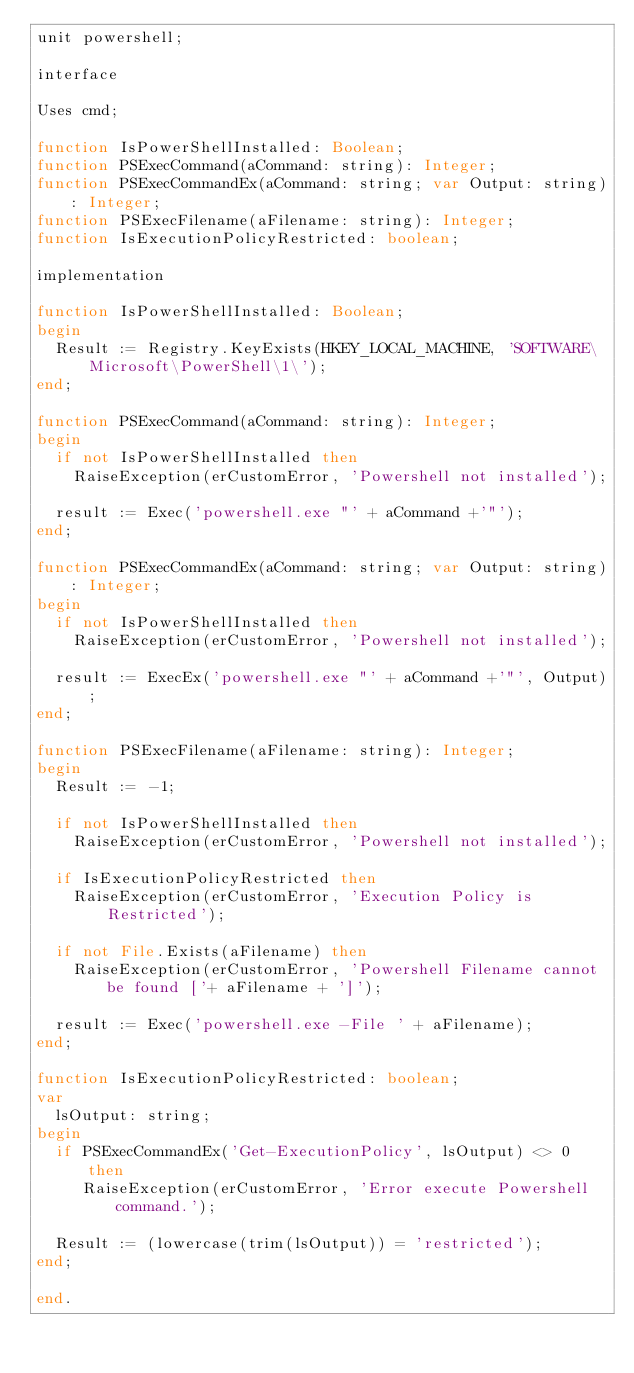Convert code to text. <code><loc_0><loc_0><loc_500><loc_500><_Pascal_>unit powershell;

interface

Uses cmd;

function IsPowerShellInstalled: Boolean;
function PSExecCommand(aCommand: string): Integer;
function PSExecCommandEx(aCommand: string; var Output: string): Integer;
function PSExecFilename(aFilename: string): Integer;
function IsExecutionPolicyRestricted: boolean;

implementation

function IsPowerShellInstalled: Boolean;
begin
  Result := Registry.KeyExists(HKEY_LOCAL_MACHINE, 'SOFTWARE\Microsoft\PowerShell\1\');
end;

function PSExecCommand(aCommand: string): Integer;
begin
  if not IsPowerShellInstalled then
    RaiseException(erCustomError, 'Powershell not installed'); 
  
  result := Exec('powershell.exe "' + aCommand +'"');
end;

function PSExecCommandEx(aCommand: string; var Output: string): Integer;
begin
  if not IsPowerShellInstalled then
    RaiseException(erCustomError, 'Powershell not installed'); 

  result := ExecEx('powershell.exe "' + aCommand +'"', Output);
end;

function PSExecFilename(aFilename: string): Integer;
begin
  Result := -1;

  if not IsPowerShellInstalled then
    RaiseException(erCustomError, 'Powershell not installed'); 

  if IsExecutionPolicyRestricted then 
    RaiseException(erCustomError, 'Execution Policy is Restricted');  
  
  if not File.Exists(aFilename) then
    RaiseException(erCustomError, 'Powershell Filename cannot be found ['+ aFilename + ']');

  result := Exec('powershell.exe -File ' + aFilename);
end;

function IsExecutionPolicyRestricted: boolean;
var 
  lsOutput: string;
begin
  if PSExecCommandEx('Get-ExecutionPolicy', lsOutput) <> 0 then
     RaiseException(erCustomError, 'Error execute Powershell command.');

  Result := (lowercase(trim(lsOutput)) = 'restricted');   
end;

end.


</code> 